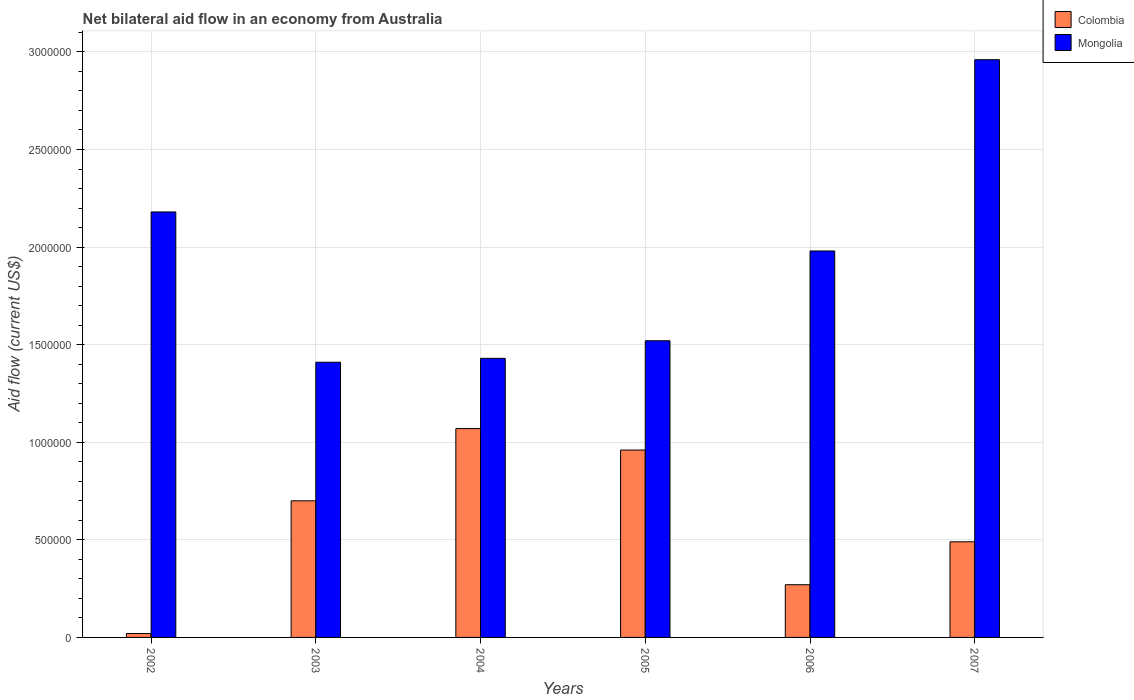Are the number of bars per tick equal to the number of legend labels?
Provide a succinct answer. Yes. In how many cases, is the number of bars for a given year not equal to the number of legend labels?
Provide a succinct answer. 0. What is the net bilateral aid flow in Mongolia in 2003?
Your response must be concise. 1.41e+06. Across all years, what is the maximum net bilateral aid flow in Mongolia?
Your answer should be very brief. 2.96e+06. Across all years, what is the minimum net bilateral aid flow in Mongolia?
Give a very brief answer. 1.41e+06. In which year was the net bilateral aid flow in Mongolia minimum?
Ensure brevity in your answer.  2003. What is the total net bilateral aid flow in Colombia in the graph?
Make the answer very short. 3.51e+06. What is the difference between the net bilateral aid flow in Colombia in 2002 and that in 2007?
Make the answer very short. -4.70e+05. What is the difference between the net bilateral aid flow in Colombia in 2007 and the net bilateral aid flow in Mongolia in 2004?
Provide a short and direct response. -9.40e+05. What is the average net bilateral aid flow in Mongolia per year?
Make the answer very short. 1.91e+06. In the year 2007, what is the difference between the net bilateral aid flow in Colombia and net bilateral aid flow in Mongolia?
Provide a succinct answer. -2.47e+06. What is the ratio of the net bilateral aid flow in Mongolia in 2005 to that in 2006?
Make the answer very short. 0.77. Is the net bilateral aid flow in Colombia in 2003 less than that in 2007?
Your answer should be very brief. No. What is the difference between the highest and the second highest net bilateral aid flow in Colombia?
Provide a succinct answer. 1.10e+05. What is the difference between the highest and the lowest net bilateral aid flow in Colombia?
Your answer should be very brief. 1.05e+06. In how many years, is the net bilateral aid flow in Mongolia greater than the average net bilateral aid flow in Mongolia taken over all years?
Provide a succinct answer. 3. Is the sum of the net bilateral aid flow in Colombia in 2002 and 2004 greater than the maximum net bilateral aid flow in Mongolia across all years?
Provide a short and direct response. No. What does the 2nd bar from the left in 2005 represents?
Provide a short and direct response. Mongolia. What does the 1st bar from the right in 2003 represents?
Offer a very short reply. Mongolia. Does the graph contain any zero values?
Give a very brief answer. No. How many legend labels are there?
Offer a terse response. 2. How are the legend labels stacked?
Your answer should be compact. Vertical. What is the title of the graph?
Provide a succinct answer. Net bilateral aid flow in an economy from Australia. Does "Canada" appear as one of the legend labels in the graph?
Give a very brief answer. No. What is the Aid flow (current US$) in Mongolia in 2002?
Offer a very short reply. 2.18e+06. What is the Aid flow (current US$) in Colombia in 2003?
Make the answer very short. 7.00e+05. What is the Aid flow (current US$) in Mongolia in 2003?
Provide a succinct answer. 1.41e+06. What is the Aid flow (current US$) in Colombia in 2004?
Your answer should be compact. 1.07e+06. What is the Aid flow (current US$) of Mongolia in 2004?
Your answer should be compact. 1.43e+06. What is the Aid flow (current US$) of Colombia in 2005?
Provide a short and direct response. 9.60e+05. What is the Aid flow (current US$) in Mongolia in 2005?
Make the answer very short. 1.52e+06. What is the Aid flow (current US$) in Mongolia in 2006?
Your answer should be compact. 1.98e+06. What is the Aid flow (current US$) of Mongolia in 2007?
Your answer should be very brief. 2.96e+06. Across all years, what is the maximum Aid flow (current US$) of Colombia?
Your answer should be compact. 1.07e+06. Across all years, what is the maximum Aid flow (current US$) of Mongolia?
Give a very brief answer. 2.96e+06. Across all years, what is the minimum Aid flow (current US$) of Colombia?
Offer a terse response. 2.00e+04. Across all years, what is the minimum Aid flow (current US$) in Mongolia?
Make the answer very short. 1.41e+06. What is the total Aid flow (current US$) in Colombia in the graph?
Ensure brevity in your answer.  3.51e+06. What is the total Aid flow (current US$) of Mongolia in the graph?
Keep it short and to the point. 1.15e+07. What is the difference between the Aid flow (current US$) of Colombia in 2002 and that in 2003?
Provide a short and direct response. -6.80e+05. What is the difference between the Aid flow (current US$) in Mongolia in 2002 and that in 2003?
Keep it short and to the point. 7.70e+05. What is the difference between the Aid flow (current US$) in Colombia in 2002 and that in 2004?
Your response must be concise. -1.05e+06. What is the difference between the Aid flow (current US$) of Mongolia in 2002 and that in 2004?
Your answer should be very brief. 7.50e+05. What is the difference between the Aid flow (current US$) of Colombia in 2002 and that in 2005?
Your answer should be very brief. -9.40e+05. What is the difference between the Aid flow (current US$) of Mongolia in 2002 and that in 2005?
Keep it short and to the point. 6.60e+05. What is the difference between the Aid flow (current US$) in Colombia in 2002 and that in 2006?
Offer a terse response. -2.50e+05. What is the difference between the Aid flow (current US$) of Colombia in 2002 and that in 2007?
Make the answer very short. -4.70e+05. What is the difference between the Aid flow (current US$) of Mongolia in 2002 and that in 2007?
Provide a short and direct response. -7.80e+05. What is the difference between the Aid flow (current US$) in Colombia in 2003 and that in 2004?
Your answer should be compact. -3.70e+05. What is the difference between the Aid flow (current US$) of Mongolia in 2003 and that in 2004?
Offer a very short reply. -2.00e+04. What is the difference between the Aid flow (current US$) of Colombia in 2003 and that in 2005?
Offer a terse response. -2.60e+05. What is the difference between the Aid flow (current US$) of Mongolia in 2003 and that in 2005?
Ensure brevity in your answer.  -1.10e+05. What is the difference between the Aid flow (current US$) in Colombia in 2003 and that in 2006?
Make the answer very short. 4.30e+05. What is the difference between the Aid flow (current US$) in Mongolia in 2003 and that in 2006?
Make the answer very short. -5.70e+05. What is the difference between the Aid flow (current US$) in Colombia in 2003 and that in 2007?
Make the answer very short. 2.10e+05. What is the difference between the Aid flow (current US$) of Mongolia in 2003 and that in 2007?
Offer a very short reply. -1.55e+06. What is the difference between the Aid flow (current US$) of Colombia in 2004 and that in 2006?
Your answer should be very brief. 8.00e+05. What is the difference between the Aid flow (current US$) of Mongolia in 2004 and that in 2006?
Your answer should be very brief. -5.50e+05. What is the difference between the Aid flow (current US$) in Colombia in 2004 and that in 2007?
Your response must be concise. 5.80e+05. What is the difference between the Aid flow (current US$) in Mongolia in 2004 and that in 2007?
Ensure brevity in your answer.  -1.53e+06. What is the difference between the Aid flow (current US$) in Colombia in 2005 and that in 2006?
Give a very brief answer. 6.90e+05. What is the difference between the Aid flow (current US$) in Mongolia in 2005 and that in 2006?
Make the answer very short. -4.60e+05. What is the difference between the Aid flow (current US$) in Colombia in 2005 and that in 2007?
Your response must be concise. 4.70e+05. What is the difference between the Aid flow (current US$) of Mongolia in 2005 and that in 2007?
Provide a succinct answer. -1.44e+06. What is the difference between the Aid flow (current US$) in Mongolia in 2006 and that in 2007?
Make the answer very short. -9.80e+05. What is the difference between the Aid flow (current US$) of Colombia in 2002 and the Aid flow (current US$) of Mongolia in 2003?
Make the answer very short. -1.39e+06. What is the difference between the Aid flow (current US$) in Colombia in 2002 and the Aid flow (current US$) in Mongolia in 2004?
Ensure brevity in your answer.  -1.41e+06. What is the difference between the Aid flow (current US$) in Colombia in 2002 and the Aid flow (current US$) in Mongolia in 2005?
Offer a very short reply. -1.50e+06. What is the difference between the Aid flow (current US$) in Colombia in 2002 and the Aid flow (current US$) in Mongolia in 2006?
Provide a short and direct response. -1.96e+06. What is the difference between the Aid flow (current US$) of Colombia in 2002 and the Aid flow (current US$) of Mongolia in 2007?
Give a very brief answer. -2.94e+06. What is the difference between the Aid flow (current US$) in Colombia in 2003 and the Aid flow (current US$) in Mongolia in 2004?
Your response must be concise. -7.30e+05. What is the difference between the Aid flow (current US$) of Colombia in 2003 and the Aid flow (current US$) of Mongolia in 2005?
Offer a terse response. -8.20e+05. What is the difference between the Aid flow (current US$) of Colombia in 2003 and the Aid flow (current US$) of Mongolia in 2006?
Provide a succinct answer. -1.28e+06. What is the difference between the Aid flow (current US$) of Colombia in 2003 and the Aid flow (current US$) of Mongolia in 2007?
Provide a short and direct response. -2.26e+06. What is the difference between the Aid flow (current US$) of Colombia in 2004 and the Aid flow (current US$) of Mongolia in 2005?
Offer a terse response. -4.50e+05. What is the difference between the Aid flow (current US$) in Colombia in 2004 and the Aid flow (current US$) in Mongolia in 2006?
Make the answer very short. -9.10e+05. What is the difference between the Aid flow (current US$) in Colombia in 2004 and the Aid flow (current US$) in Mongolia in 2007?
Keep it short and to the point. -1.89e+06. What is the difference between the Aid flow (current US$) in Colombia in 2005 and the Aid flow (current US$) in Mongolia in 2006?
Your answer should be compact. -1.02e+06. What is the difference between the Aid flow (current US$) in Colombia in 2006 and the Aid flow (current US$) in Mongolia in 2007?
Make the answer very short. -2.69e+06. What is the average Aid flow (current US$) of Colombia per year?
Offer a very short reply. 5.85e+05. What is the average Aid flow (current US$) in Mongolia per year?
Give a very brief answer. 1.91e+06. In the year 2002, what is the difference between the Aid flow (current US$) in Colombia and Aid flow (current US$) in Mongolia?
Provide a succinct answer. -2.16e+06. In the year 2003, what is the difference between the Aid flow (current US$) in Colombia and Aid flow (current US$) in Mongolia?
Your answer should be compact. -7.10e+05. In the year 2004, what is the difference between the Aid flow (current US$) in Colombia and Aid flow (current US$) in Mongolia?
Your response must be concise. -3.60e+05. In the year 2005, what is the difference between the Aid flow (current US$) in Colombia and Aid flow (current US$) in Mongolia?
Provide a succinct answer. -5.60e+05. In the year 2006, what is the difference between the Aid flow (current US$) in Colombia and Aid flow (current US$) in Mongolia?
Give a very brief answer. -1.71e+06. In the year 2007, what is the difference between the Aid flow (current US$) of Colombia and Aid flow (current US$) of Mongolia?
Your answer should be very brief. -2.47e+06. What is the ratio of the Aid flow (current US$) of Colombia in 2002 to that in 2003?
Give a very brief answer. 0.03. What is the ratio of the Aid flow (current US$) in Mongolia in 2002 to that in 2003?
Provide a succinct answer. 1.55. What is the ratio of the Aid flow (current US$) of Colombia in 2002 to that in 2004?
Provide a succinct answer. 0.02. What is the ratio of the Aid flow (current US$) of Mongolia in 2002 to that in 2004?
Ensure brevity in your answer.  1.52. What is the ratio of the Aid flow (current US$) of Colombia in 2002 to that in 2005?
Ensure brevity in your answer.  0.02. What is the ratio of the Aid flow (current US$) of Mongolia in 2002 to that in 2005?
Give a very brief answer. 1.43. What is the ratio of the Aid flow (current US$) of Colombia in 2002 to that in 2006?
Provide a short and direct response. 0.07. What is the ratio of the Aid flow (current US$) of Mongolia in 2002 to that in 2006?
Ensure brevity in your answer.  1.1. What is the ratio of the Aid flow (current US$) of Colombia in 2002 to that in 2007?
Offer a terse response. 0.04. What is the ratio of the Aid flow (current US$) in Mongolia in 2002 to that in 2007?
Give a very brief answer. 0.74. What is the ratio of the Aid flow (current US$) of Colombia in 2003 to that in 2004?
Your answer should be very brief. 0.65. What is the ratio of the Aid flow (current US$) of Colombia in 2003 to that in 2005?
Keep it short and to the point. 0.73. What is the ratio of the Aid flow (current US$) in Mongolia in 2003 to that in 2005?
Offer a terse response. 0.93. What is the ratio of the Aid flow (current US$) of Colombia in 2003 to that in 2006?
Ensure brevity in your answer.  2.59. What is the ratio of the Aid flow (current US$) in Mongolia in 2003 to that in 2006?
Provide a succinct answer. 0.71. What is the ratio of the Aid flow (current US$) of Colombia in 2003 to that in 2007?
Ensure brevity in your answer.  1.43. What is the ratio of the Aid flow (current US$) of Mongolia in 2003 to that in 2007?
Give a very brief answer. 0.48. What is the ratio of the Aid flow (current US$) of Colombia in 2004 to that in 2005?
Make the answer very short. 1.11. What is the ratio of the Aid flow (current US$) in Mongolia in 2004 to that in 2005?
Your response must be concise. 0.94. What is the ratio of the Aid flow (current US$) in Colombia in 2004 to that in 2006?
Offer a terse response. 3.96. What is the ratio of the Aid flow (current US$) of Mongolia in 2004 to that in 2006?
Offer a terse response. 0.72. What is the ratio of the Aid flow (current US$) in Colombia in 2004 to that in 2007?
Offer a very short reply. 2.18. What is the ratio of the Aid flow (current US$) of Mongolia in 2004 to that in 2007?
Keep it short and to the point. 0.48. What is the ratio of the Aid flow (current US$) in Colombia in 2005 to that in 2006?
Offer a very short reply. 3.56. What is the ratio of the Aid flow (current US$) of Mongolia in 2005 to that in 2006?
Offer a very short reply. 0.77. What is the ratio of the Aid flow (current US$) in Colombia in 2005 to that in 2007?
Your answer should be very brief. 1.96. What is the ratio of the Aid flow (current US$) of Mongolia in 2005 to that in 2007?
Provide a succinct answer. 0.51. What is the ratio of the Aid flow (current US$) in Colombia in 2006 to that in 2007?
Ensure brevity in your answer.  0.55. What is the ratio of the Aid flow (current US$) of Mongolia in 2006 to that in 2007?
Provide a succinct answer. 0.67. What is the difference between the highest and the second highest Aid flow (current US$) of Mongolia?
Give a very brief answer. 7.80e+05. What is the difference between the highest and the lowest Aid flow (current US$) in Colombia?
Your answer should be compact. 1.05e+06. What is the difference between the highest and the lowest Aid flow (current US$) of Mongolia?
Your answer should be very brief. 1.55e+06. 